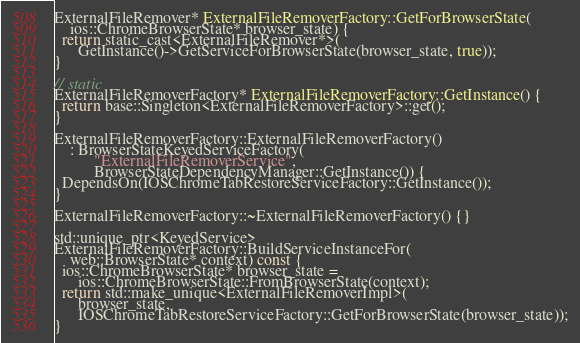<code> <loc_0><loc_0><loc_500><loc_500><_ObjectiveC_>ExternalFileRemover* ExternalFileRemoverFactory::GetForBrowserState(
    ios::ChromeBrowserState* browser_state) {
  return static_cast<ExternalFileRemover*>(
      GetInstance()->GetServiceForBrowserState(browser_state, true));
}

// static
ExternalFileRemoverFactory* ExternalFileRemoverFactory::GetInstance() {
  return base::Singleton<ExternalFileRemoverFactory>::get();
}

ExternalFileRemoverFactory::ExternalFileRemoverFactory()
    : BrowserStateKeyedServiceFactory(
          "ExternalFileRemoverService",
          BrowserStateDependencyManager::GetInstance()) {
  DependsOn(IOSChromeTabRestoreServiceFactory::GetInstance());
}

ExternalFileRemoverFactory::~ExternalFileRemoverFactory() {}

std::unique_ptr<KeyedService>
ExternalFileRemoverFactory::BuildServiceInstanceFor(
    web::BrowserState* context) const {
  ios::ChromeBrowserState* browser_state =
      ios::ChromeBrowserState::FromBrowserState(context);
  return std::make_unique<ExternalFileRemoverImpl>(
      browser_state,
      IOSChromeTabRestoreServiceFactory::GetForBrowserState(browser_state));
}
</code> 